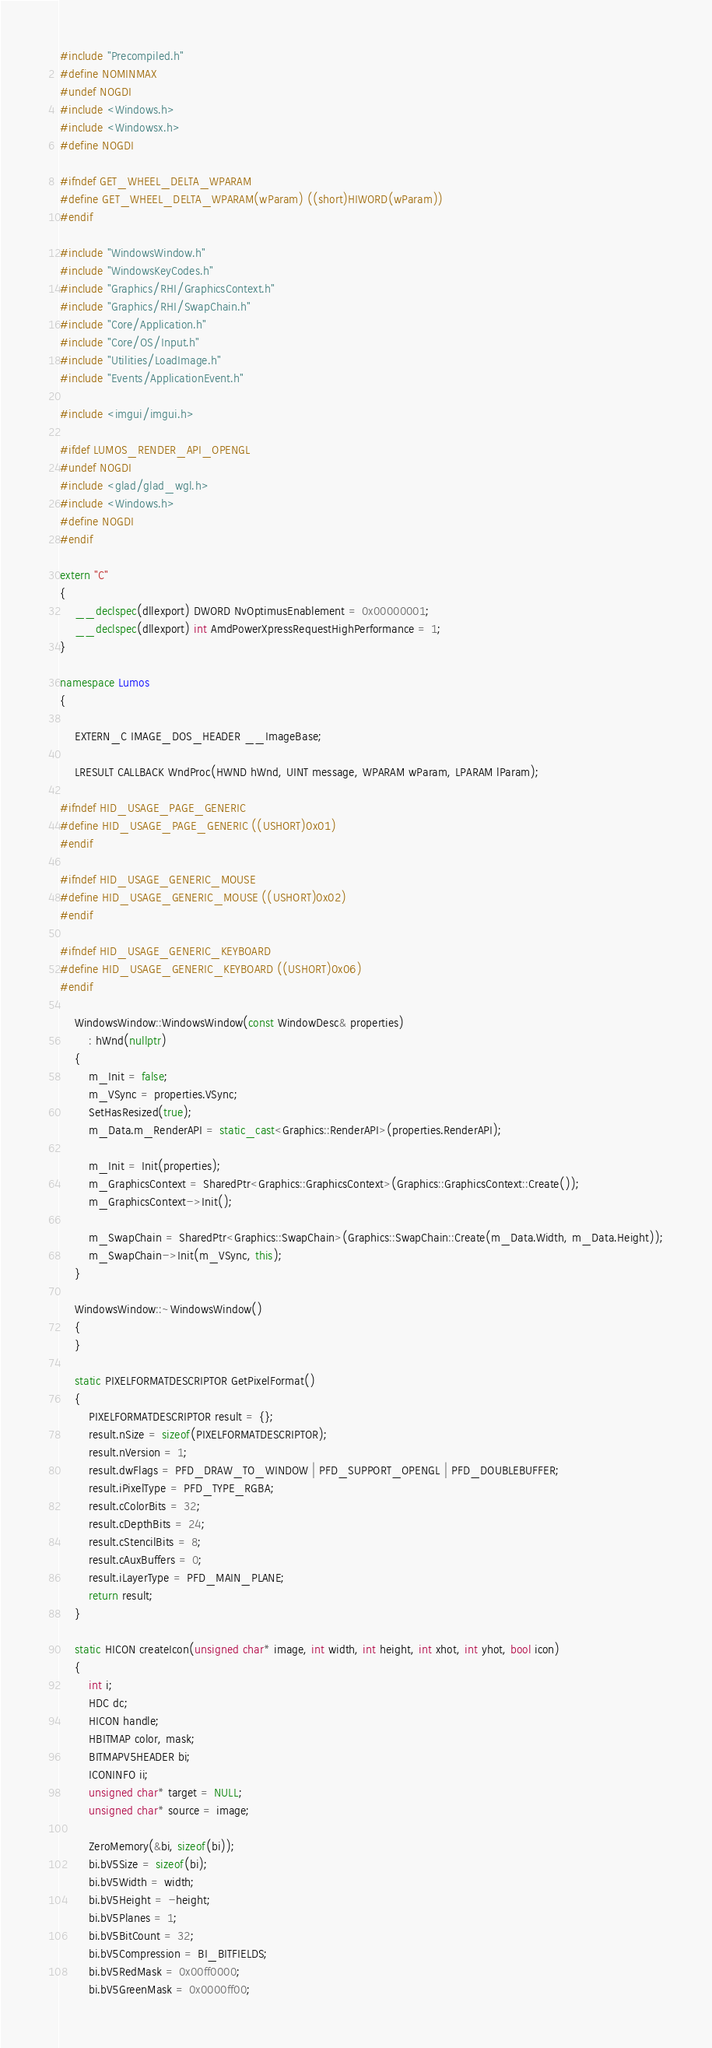Convert code to text. <code><loc_0><loc_0><loc_500><loc_500><_C++_>#include "Precompiled.h"
#define NOMINMAX
#undef NOGDI
#include <Windows.h>
#include <Windowsx.h>
#define NOGDI

#ifndef GET_WHEEL_DELTA_WPARAM
#define GET_WHEEL_DELTA_WPARAM(wParam) ((short)HIWORD(wParam))
#endif

#include "WindowsWindow.h"
#include "WindowsKeyCodes.h"
#include "Graphics/RHI/GraphicsContext.h"
#include "Graphics/RHI/SwapChain.h"
#include "Core/Application.h"
#include "Core/OS/Input.h"
#include "Utilities/LoadImage.h"
#include "Events/ApplicationEvent.h"

#include <imgui/imgui.h>

#ifdef LUMOS_RENDER_API_OPENGL
#undef NOGDI
#include <glad/glad_wgl.h>
#include <Windows.h>
#define NOGDI
#endif

extern "C"
{
    __declspec(dllexport) DWORD NvOptimusEnablement = 0x00000001;
    __declspec(dllexport) int AmdPowerXpressRequestHighPerformance = 1;
}

namespace Lumos
{

    EXTERN_C IMAGE_DOS_HEADER __ImageBase;

    LRESULT CALLBACK WndProc(HWND hWnd, UINT message, WPARAM wParam, LPARAM lParam);

#ifndef HID_USAGE_PAGE_GENERIC
#define HID_USAGE_PAGE_GENERIC ((USHORT)0x01)
#endif

#ifndef HID_USAGE_GENERIC_MOUSE
#define HID_USAGE_GENERIC_MOUSE ((USHORT)0x02)
#endif

#ifndef HID_USAGE_GENERIC_KEYBOARD
#define HID_USAGE_GENERIC_KEYBOARD ((USHORT)0x06)
#endif

    WindowsWindow::WindowsWindow(const WindowDesc& properties)
        : hWnd(nullptr)
    {
        m_Init = false;
        m_VSync = properties.VSync;
        SetHasResized(true);
        m_Data.m_RenderAPI = static_cast<Graphics::RenderAPI>(properties.RenderAPI);

        m_Init = Init(properties);
        m_GraphicsContext = SharedPtr<Graphics::GraphicsContext>(Graphics::GraphicsContext::Create());
        m_GraphicsContext->Init();

        m_SwapChain = SharedPtr<Graphics::SwapChain>(Graphics::SwapChain::Create(m_Data.Width, m_Data.Height));
        m_SwapChain->Init(m_VSync, this);
    }

    WindowsWindow::~WindowsWindow()
    {
    }

    static PIXELFORMATDESCRIPTOR GetPixelFormat()
    {
        PIXELFORMATDESCRIPTOR result = {};
        result.nSize = sizeof(PIXELFORMATDESCRIPTOR);
        result.nVersion = 1;
        result.dwFlags = PFD_DRAW_TO_WINDOW | PFD_SUPPORT_OPENGL | PFD_DOUBLEBUFFER;
        result.iPixelType = PFD_TYPE_RGBA;
        result.cColorBits = 32;
        result.cDepthBits = 24;
        result.cStencilBits = 8;
        result.cAuxBuffers = 0;
        result.iLayerType = PFD_MAIN_PLANE;
        return result;
    }

    static HICON createIcon(unsigned char* image, int width, int height, int xhot, int yhot, bool icon)
    {
        int i;
        HDC dc;
        HICON handle;
        HBITMAP color, mask;
        BITMAPV5HEADER bi;
        ICONINFO ii;
        unsigned char* target = NULL;
        unsigned char* source = image;

        ZeroMemory(&bi, sizeof(bi));
        bi.bV5Size = sizeof(bi);
        bi.bV5Width = width;
        bi.bV5Height = -height;
        bi.bV5Planes = 1;
        bi.bV5BitCount = 32;
        bi.bV5Compression = BI_BITFIELDS;
        bi.bV5RedMask = 0x00ff0000;
        bi.bV5GreenMask = 0x0000ff00;</code> 